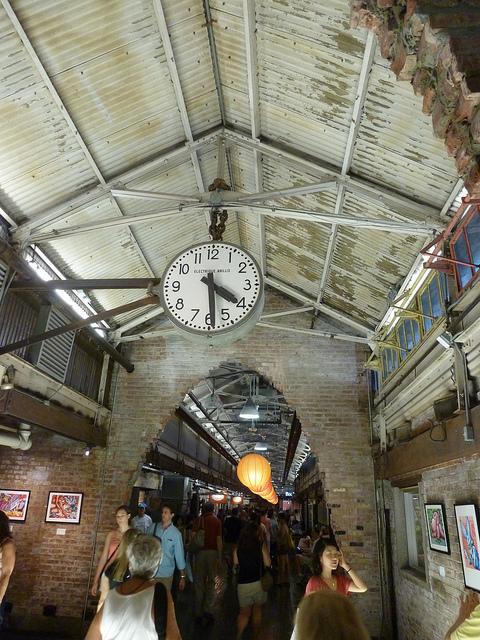What are people doing here?
Answer briefly. Walking. Is there art on the walls?
Be succinct. Yes. What time is it?
Answer briefly. 4:30. 